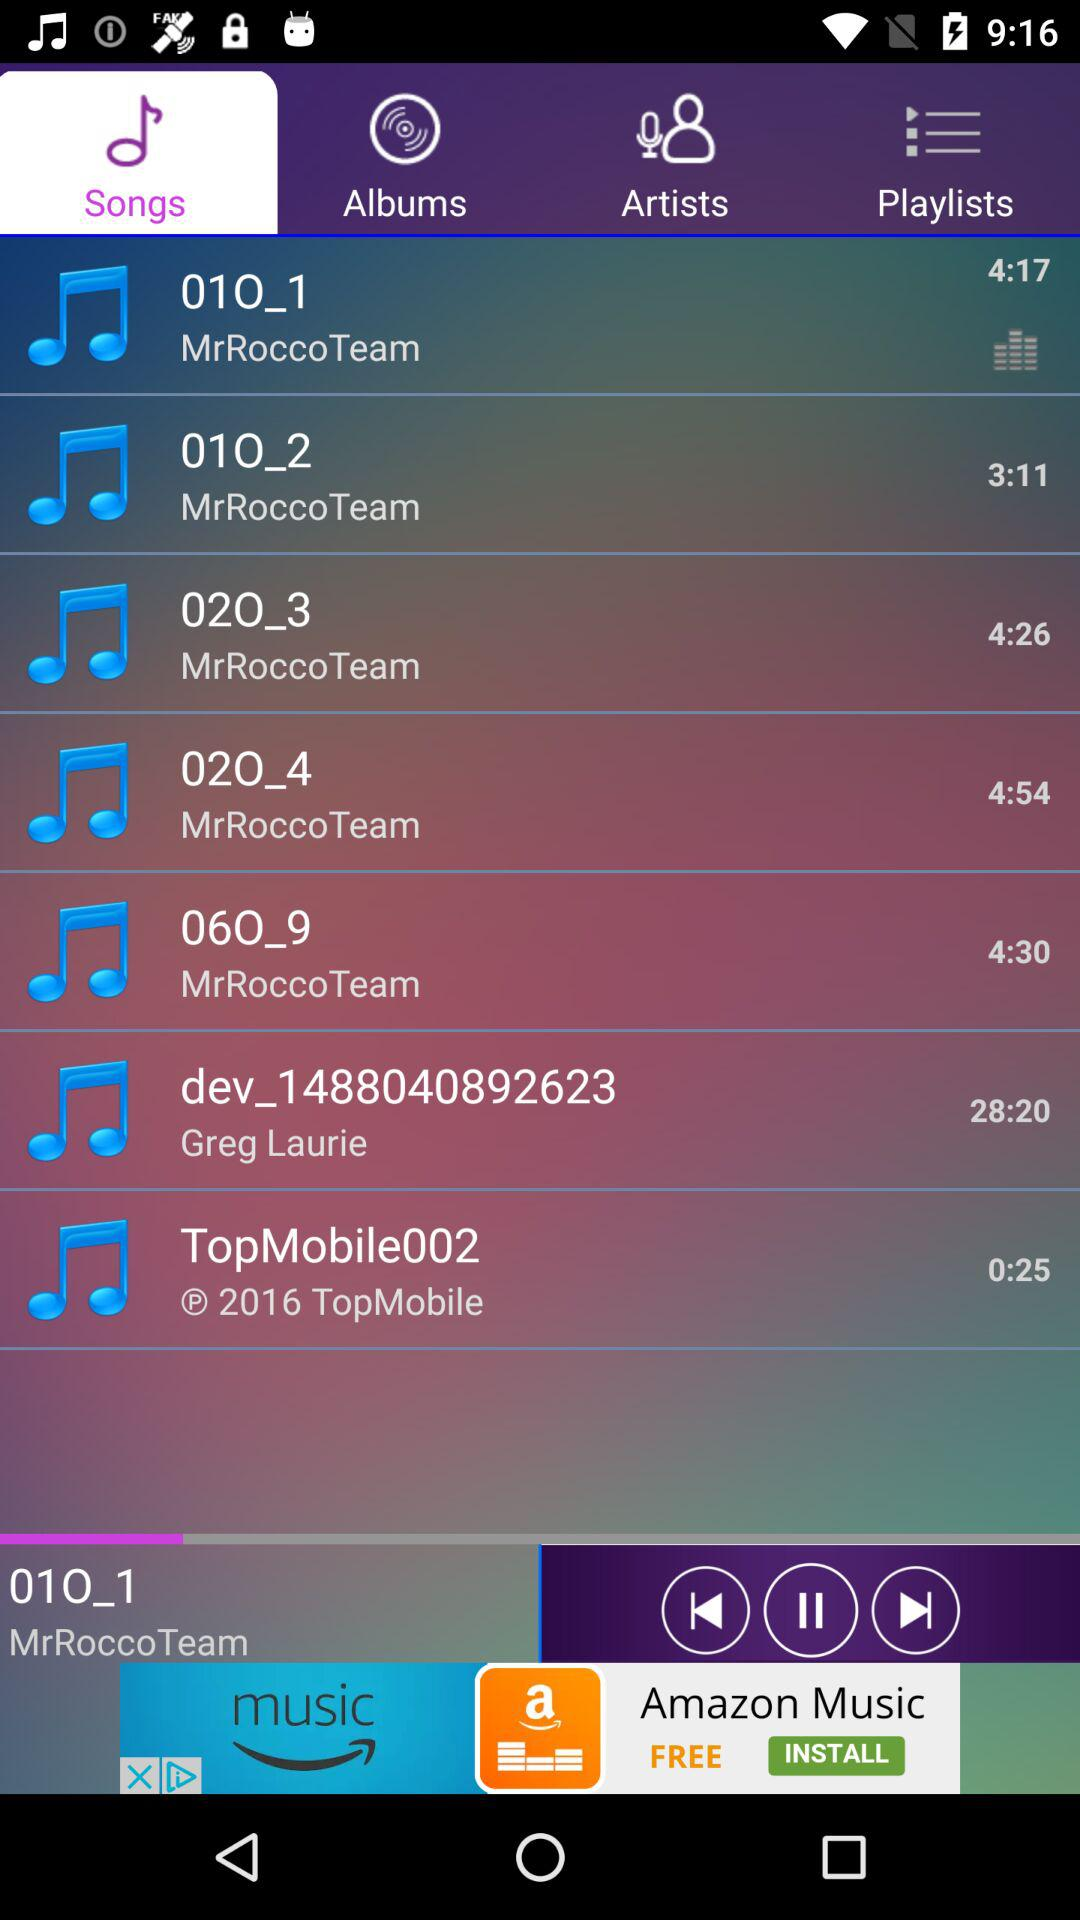Which tab is selected? The selected tab is "Songs". 